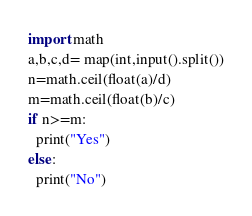Convert code to text. <code><loc_0><loc_0><loc_500><loc_500><_Python_>import math
a,b,c,d= map(int,input().split())
n=math.ceil(float(a)/d)
m=math.ceil(float(b)/c)
if n>=m:
  print("Yes")
else:
  print("No")</code> 